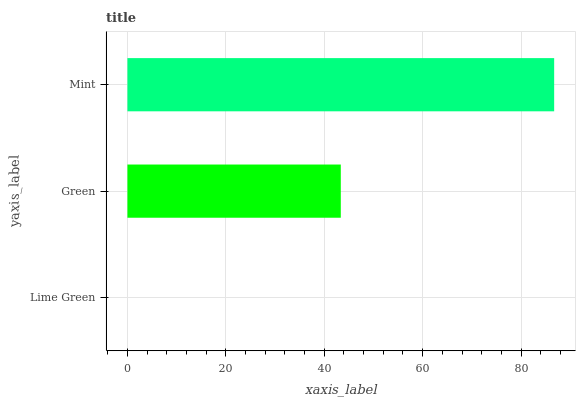Is Lime Green the minimum?
Answer yes or no. Yes. Is Mint the maximum?
Answer yes or no. Yes. Is Green the minimum?
Answer yes or no. No. Is Green the maximum?
Answer yes or no. No. Is Green greater than Lime Green?
Answer yes or no. Yes. Is Lime Green less than Green?
Answer yes or no. Yes. Is Lime Green greater than Green?
Answer yes or no. No. Is Green less than Lime Green?
Answer yes or no. No. Is Green the high median?
Answer yes or no. Yes. Is Green the low median?
Answer yes or no. Yes. Is Lime Green the high median?
Answer yes or no. No. Is Mint the low median?
Answer yes or no. No. 